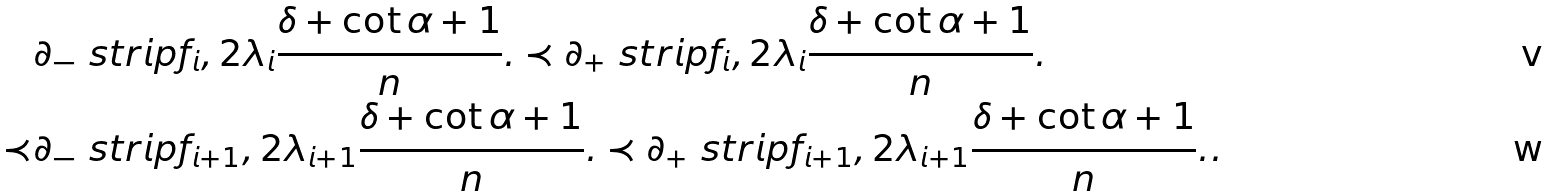Convert formula to latex. <formula><loc_0><loc_0><loc_500><loc_500>& \partial _ { - } \ s t r i p f _ { i } , 2 \lambda _ { i } \frac { \delta + \cot \alpha + 1 } { n } . \prec \partial _ { + } \ s t r i p f _ { i } , 2 \lambda _ { i } \frac { \delta + \cot \alpha + 1 } { n } . \\ \prec & \partial _ { - } \ s t r i p f _ { i + 1 } , 2 \lambda _ { i + 1 } \frac { \delta + \cot \alpha + 1 } { n } . \prec \partial _ { + } \ s t r i p f _ { i + 1 } , 2 \lambda _ { i + 1 } \frac { \delta + \cot \alpha + 1 } { n } . .</formula> 